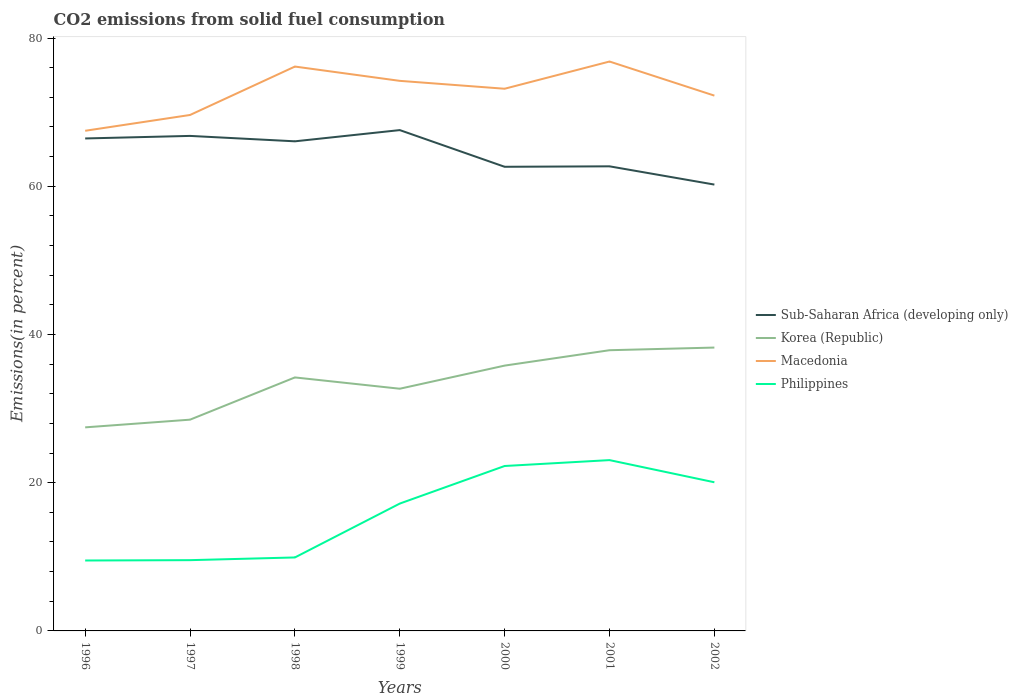Does the line corresponding to Philippines intersect with the line corresponding to Korea (Republic)?
Provide a short and direct response. No. Is the number of lines equal to the number of legend labels?
Offer a terse response. Yes. Across all years, what is the maximum total CO2 emitted in Macedonia?
Give a very brief answer. 67.49. What is the total total CO2 emitted in Korea (Republic) in the graph?
Keep it short and to the point. -4.03. What is the difference between the highest and the second highest total CO2 emitted in Sub-Saharan Africa (developing only)?
Your response must be concise. 7.35. What is the difference between the highest and the lowest total CO2 emitted in Sub-Saharan Africa (developing only)?
Your answer should be very brief. 4. Is the total CO2 emitted in Sub-Saharan Africa (developing only) strictly greater than the total CO2 emitted in Philippines over the years?
Make the answer very short. No. How many lines are there?
Make the answer very short. 4. How many years are there in the graph?
Your answer should be very brief. 7. Does the graph contain any zero values?
Keep it short and to the point. No. Does the graph contain grids?
Your answer should be very brief. No. Where does the legend appear in the graph?
Provide a short and direct response. Center right. What is the title of the graph?
Your answer should be compact. CO2 emissions from solid fuel consumption. Does "Qatar" appear as one of the legend labels in the graph?
Provide a short and direct response. No. What is the label or title of the X-axis?
Your answer should be compact. Years. What is the label or title of the Y-axis?
Offer a terse response. Emissions(in percent). What is the Emissions(in percent) of Sub-Saharan Africa (developing only) in 1996?
Give a very brief answer. 66.45. What is the Emissions(in percent) in Korea (Republic) in 1996?
Offer a very short reply. 27.47. What is the Emissions(in percent) in Macedonia in 1996?
Keep it short and to the point. 67.49. What is the Emissions(in percent) in Philippines in 1996?
Your answer should be very brief. 9.5. What is the Emissions(in percent) in Sub-Saharan Africa (developing only) in 1997?
Your answer should be compact. 66.8. What is the Emissions(in percent) in Korea (Republic) in 1997?
Your answer should be compact. 28.51. What is the Emissions(in percent) of Macedonia in 1997?
Your answer should be very brief. 69.62. What is the Emissions(in percent) in Philippines in 1997?
Keep it short and to the point. 9.55. What is the Emissions(in percent) of Sub-Saharan Africa (developing only) in 1998?
Your answer should be compact. 66.07. What is the Emissions(in percent) in Korea (Republic) in 1998?
Keep it short and to the point. 34.21. What is the Emissions(in percent) in Macedonia in 1998?
Your answer should be very brief. 76.15. What is the Emissions(in percent) of Philippines in 1998?
Offer a very short reply. 9.91. What is the Emissions(in percent) of Sub-Saharan Africa (developing only) in 1999?
Your answer should be compact. 67.58. What is the Emissions(in percent) of Korea (Republic) in 1999?
Your response must be concise. 32.68. What is the Emissions(in percent) of Macedonia in 1999?
Your answer should be compact. 74.23. What is the Emissions(in percent) in Philippines in 1999?
Ensure brevity in your answer.  17.18. What is the Emissions(in percent) in Sub-Saharan Africa (developing only) in 2000?
Keep it short and to the point. 62.63. What is the Emissions(in percent) of Korea (Republic) in 2000?
Offer a very short reply. 35.8. What is the Emissions(in percent) of Macedonia in 2000?
Your answer should be very brief. 73.16. What is the Emissions(in percent) in Philippines in 2000?
Ensure brevity in your answer.  22.26. What is the Emissions(in percent) in Sub-Saharan Africa (developing only) in 2001?
Offer a very short reply. 62.69. What is the Emissions(in percent) of Korea (Republic) in 2001?
Provide a succinct answer. 37.88. What is the Emissions(in percent) of Macedonia in 2001?
Your answer should be very brief. 76.83. What is the Emissions(in percent) in Philippines in 2001?
Your answer should be very brief. 23.05. What is the Emissions(in percent) of Sub-Saharan Africa (developing only) in 2002?
Make the answer very short. 60.23. What is the Emissions(in percent) in Korea (Republic) in 2002?
Offer a terse response. 38.24. What is the Emissions(in percent) of Macedonia in 2002?
Keep it short and to the point. 72.23. What is the Emissions(in percent) in Philippines in 2002?
Keep it short and to the point. 20.06. Across all years, what is the maximum Emissions(in percent) of Sub-Saharan Africa (developing only)?
Make the answer very short. 67.58. Across all years, what is the maximum Emissions(in percent) of Korea (Republic)?
Ensure brevity in your answer.  38.24. Across all years, what is the maximum Emissions(in percent) of Macedonia?
Provide a succinct answer. 76.83. Across all years, what is the maximum Emissions(in percent) in Philippines?
Provide a short and direct response. 23.05. Across all years, what is the minimum Emissions(in percent) of Sub-Saharan Africa (developing only)?
Give a very brief answer. 60.23. Across all years, what is the minimum Emissions(in percent) of Korea (Republic)?
Provide a succinct answer. 27.47. Across all years, what is the minimum Emissions(in percent) of Macedonia?
Keep it short and to the point. 67.49. Across all years, what is the minimum Emissions(in percent) in Philippines?
Provide a succinct answer. 9.5. What is the total Emissions(in percent) of Sub-Saharan Africa (developing only) in the graph?
Your answer should be very brief. 452.45. What is the total Emissions(in percent) in Korea (Republic) in the graph?
Your response must be concise. 234.78. What is the total Emissions(in percent) of Macedonia in the graph?
Your answer should be compact. 509.72. What is the total Emissions(in percent) in Philippines in the graph?
Ensure brevity in your answer.  111.51. What is the difference between the Emissions(in percent) in Sub-Saharan Africa (developing only) in 1996 and that in 1997?
Ensure brevity in your answer.  -0.34. What is the difference between the Emissions(in percent) in Korea (Republic) in 1996 and that in 1997?
Your response must be concise. -1.04. What is the difference between the Emissions(in percent) of Macedonia in 1996 and that in 1997?
Provide a short and direct response. -2.13. What is the difference between the Emissions(in percent) in Philippines in 1996 and that in 1997?
Your answer should be compact. -0.05. What is the difference between the Emissions(in percent) in Sub-Saharan Africa (developing only) in 1996 and that in 1998?
Offer a terse response. 0.39. What is the difference between the Emissions(in percent) in Korea (Republic) in 1996 and that in 1998?
Your answer should be very brief. -6.74. What is the difference between the Emissions(in percent) of Macedonia in 1996 and that in 1998?
Provide a short and direct response. -8.67. What is the difference between the Emissions(in percent) of Philippines in 1996 and that in 1998?
Provide a short and direct response. -0.41. What is the difference between the Emissions(in percent) of Sub-Saharan Africa (developing only) in 1996 and that in 1999?
Your response must be concise. -1.13. What is the difference between the Emissions(in percent) of Korea (Republic) in 1996 and that in 1999?
Your answer should be compact. -5.21. What is the difference between the Emissions(in percent) of Macedonia in 1996 and that in 1999?
Make the answer very short. -6.74. What is the difference between the Emissions(in percent) of Philippines in 1996 and that in 1999?
Offer a terse response. -7.68. What is the difference between the Emissions(in percent) of Sub-Saharan Africa (developing only) in 1996 and that in 2000?
Provide a short and direct response. 3.82. What is the difference between the Emissions(in percent) of Korea (Republic) in 1996 and that in 2000?
Keep it short and to the point. -8.33. What is the difference between the Emissions(in percent) of Macedonia in 1996 and that in 2000?
Your answer should be compact. -5.67. What is the difference between the Emissions(in percent) of Philippines in 1996 and that in 2000?
Keep it short and to the point. -12.75. What is the difference between the Emissions(in percent) of Sub-Saharan Africa (developing only) in 1996 and that in 2001?
Make the answer very short. 3.76. What is the difference between the Emissions(in percent) of Korea (Republic) in 1996 and that in 2001?
Your answer should be very brief. -10.41. What is the difference between the Emissions(in percent) in Macedonia in 1996 and that in 2001?
Your answer should be compact. -9.34. What is the difference between the Emissions(in percent) of Philippines in 1996 and that in 2001?
Provide a succinct answer. -13.55. What is the difference between the Emissions(in percent) of Sub-Saharan Africa (developing only) in 1996 and that in 2002?
Make the answer very short. 6.22. What is the difference between the Emissions(in percent) of Korea (Republic) in 1996 and that in 2002?
Your answer should be very brief. -10.77. What is the difference between the Emissions(in percent) in Macedonia in 1996 and that in 2002?
Provide a succinct answer. -4.74. What is the difference between the Emissions(in percent) of Philippines in 1996 and that in 2002?
Ensure brevity in your answer.  -10.55. What is the difference between the Emissions(in percent) of Sub-Saharan Africa (developing only) in 1997 and that in 1998?
Provide a short and direct response. 0.73. What is the difference between the Emissions(in percent) of Korea (Republic) in 1997 and that in 1998?
Your response must be concise. -5.7. What is the difference between the Emissions(in percent) in Macedonia in 1997 and that in 1998?
Make the answer very short. -6.53. What is the difference between the Emissions(in percent) in Philippines in 1997 and that in 1998?
Ensure brevity in your answer.  -0.37. What is the difference between the Emissions(in percent) in Sub-Saharan Africa (developing only) in 1997 and that in 1999?
Provide a succinct answer. -0.78. What is the difference between the Emissions(in percent) of Korea (Republic) in 1997 and that in 1999?
Offer a terse response. -4.17. What is the difference between the Emissions(in percent) in Macedonia in 1997 and that in 1999?
Provide a succinct answer. -4.61. What is the difference between the Emissions(in percent) of Philippines in 1997 and that in 1999?
Provide a succinct answer. -7.64. What is the difference between the Emissions(in percent) in Sub-Saharan Africa (developing only) in 1997 and that in 2000?
Keep it short and to the point. 4.17. What is the difference between the Emissions(in percent) in Korea (Republic) in 1997 and that in 2000?
Your answer should be very brief. -7.3. What is the difference between the Emissions(in percent) in Macedonia in 1997 and that in 2000?
Keep it short and to the point. -3.54. What is the difference between the Emissions(in percent) in Philippines in 1997 and that in 2000?
Your answer should be very brief. -12.71. What is the difference between the Emissions(in percent) in Sub-Saharan Africa (developing only) in 1997 and that in 2001?
Make the answer very short. 4.1. What is the difference between the Emissions(in percent) of Korea (Republic) in 1997 and that in 2001?
Give a very brief answer. -9.37. What is the difference between the Emissions(in percent) in Macedonia in 1997 and that in 2001?
Your answer should be compact. -7.21. What is the difference between the Emissions(in percent) of Philippines in 1997 and that in 2001?
Give a very brief answer. -13.5. What is the difference between the Emissions(in percent) of Sub-Saharan Africa (developing only) in 1997 and that in 2002?
Provide a short and direct response. 6.57. What is the difference between the Emissions(in percent) of Korea (Republic) in 1997 and that in 2002?
Ensure brevity in your answer.  -9.73. What is the difference between the Emissions(in percent) of Macedonia in 1997 and that in 2002?
Your response must be concise. -2.61. What is the difference between the Emissions(in percent) in Philippines in 1997 and that in 2002?
Give a very brief answer. -10.51. What is the difference between the Emissions(in percent) in Sub-Saharan Africa (developing only) in 1998 and that in 1999?
Your response must be concise. -1.51. What is the difference between the Emissions(in percent) in Korea (Republic) in 1998 and that in 1999?
Offer a terse response. 1.52. What is the difference between the Emissions(in percent) of Macedonia in 1998 and that in 1999?
Your answer should be very brief. 1.93. What is the difference between the Emissions(in percent) of Philippines in 1998 and that in 1999?
Ensure brevity in your answer.  -7.27. What is the difference between the Emissions(in percent) in Sub-Saharan Africa (developing only) in 1998 and that in 2000?
Make the answer very short. 3.44. What is the difference between the Emissions(in percent) of Korea (Republic) in 1998 and that in 2000?
Offer a terse response. -1.6. What is the difference between the Emissions(in percent) of Macedonia in 1998 and that in 2000?
Make the answer very short. 2.99. What is the difference between the Emissions(in percent) in Philippines in 1998 and that in 2000?
Offer a terse response. -12.34. What is the difference between the Emissions(in percent) in Sub-Saharan Africa (developing only) in 1998 and that in 2001?
Your answer should be very brief. 3.38. What is the difference between the Emissions(in percent) of Korea (Republic) in 1998 and that in 2001?
Give a very brief answer. -3.67. What is the difference between the Emissions(in percent) in Macedonia in 1998 and that in 2001?
Your answer should be compact. -0.68. What is the difference between the Emissions(in percent) of Philippines in 1998 and that in 2001?
Give a very brief answer. -13.13. What is the difference between the Emissions(in percent) in Sub-Saharan Africa (developing only) in 1998 and that in 2002?
Your response must be concise. 5.84. What is the difference between the Emissions(in percent) in Korea (Republic) in 1998 and that in 2002?
Offer a very short reply. -4.03. What is the difference between the Emissions(in percent) of Macedonia in 1998 and that in 2002?
Ensure brevity in your answer.  3.92. What is the difference between the Emissions(in percent) in Philippines in 1998 and that in 2002?
Your answer should be compact. -10.14. What is the difference between the Emissions(in percent) of Sub-Saharan Africa (developing only) in 1999 and that in 2000?
Keep it short and to the point. 4.95. What is the difference between the Emissions(in percent) of Korea (Republic) in 1999 and that in 2000?
Give a very brief answer. -3.12. What is the difference between the Emissions(in percent) of Macedonia in 1999 and that in 2000?
Ensure brevity in your answer.  1.06. What is the difference between the Emissions(in percent) in Philippines in 1999 and that in 2000?
Give a very brief answer. -5.07. What is the difference between the Emissions(in percent) in Sub-Saharan Africa (developing only) in 1999 and that in 2001?
Provide a short and direct response. 4.89. What is the difference between the Emissions(in percent) in Korea (Republic) in 1999 and that in 2001?
Provide a short and direct response. -5.2. What is the difference between the Emissions(in percent) in Macedonia in 1999 and that in 2001?
Your answer should be very brief. -2.61. What is the difference between the Emissions(in percent) in Philippines in 1999 and that in 2001?
Make the answer very short. -5.86. What is the difference between the Emissions(in percent) in Sub-Saharan Africa (developing only) in 1999 and that in 2002?
Provide a succinct answer. 7.35. What is the difference between the Emissions(in percent) in Korea (Republic) in 1999 and that in 2002?
Give a very brief answer. -5.56. What is the difference between the Emissions(in percent) of Macedonia in 1999 and that in 2002?
Offer a terse response. 1.99. What is the difference between the Emissions(in percent) in Philippines in 1999 and that in 2002?
Give a very brief answer. -2.87. What is the difference between the Emissions(in percent) in Sub-Saharan Africa (developing only) in 2000 and that in 2001?
Make the answer very short. -0.06. What is the difference between the Emissions(in percent) in Korea (Republic) in 2000 and that in 2001?
Make the answer very short. -2.08. What is the difference between the Emissions(in percent) of Macedonia in 2000 and that in 2001?
Your response must be concise. -3.67. What is the difference between the Emissions(in percent) of Philippines in 2000 and that in 2001?
Keep it short and to the point. -0.79. What is the difference between the Emissions(in percent) in Sub-Saharan Africa (developing only) in 2000 and that in 2002?
Make the answer very short. 2.4. What is the difference between the Emissions(in percent) in Korea (Republic) in 2000 and that in 2002?
Offer a terse response. -2.43. What is the difference between the Emissions(in percent) of Macedonia in 2000 and that in 2002?
Give a very brief answer. 0.93. What is the difference between the Emissions(in percent) of Philippines in 2000 and that in 2002?
Give a very brief answer. 2.2. What is the difference between the Emissions(in percent) in Sub-Saharan Africa (developing only) in 2001 and that in 2002?
Offer a terse response. 2.46. What is the difference between the Emissions(in percent) of Korea (Republic) in 2001 and that in 2002?
Make the answer very short. -0.36. What is the difference between the Emissions(in percent) of Macedonia in 2001 and that in 2002?
Ensure brevity in your answer.  4.6. What is the difference between the Emissions(in percent) of Philippines in 2001 and that in 2002?
Your answer should be compact. 2.99. What is the difference between the Emissions(in percent) of Sub-Saharan Africa (developing only) in 1996 and the Emissions(in percent) of Korea (Republic) in 1997?
Provide a succinct answer. 37.95. What is the difference between the Emissions(in percent) of Sub-Saharan Africa (developing only) in 1996 and the Emissions(in percent) of Macedonia in 1997?
Keep it short and to the point. -3.17. What is the difference between the Emissions(in percent) of Sub-Saharan Africa (developing only) in 1996 and the Emissions(in percent) of Philippines in 1997?
Your answer should be very brief. 56.9. What is the difference between the Emissions(in percent) in Korea (Republic) in 1996 and the Emissions(in percent) in Macedonia in 1997?
Provide a short and direct response. -42.15. What is the difference between the Emissions(in percent) of Korea (Republic) in 1996 and the Emissions(in percent) of Philippines in 1997?
Your answer should be compact. 17.92. What is the difference between the Emissions(in percent) in Macedonia in 1996 and the Emissions(in percent) in Philippines in 1997?
Your answer should be compact. 57.94. What is the difference between the Emissions(in percent) in Sub-Saharan Africa (developing only) in 1996 and the Emissions(in percent) in Korea (Republic) in 1998?
Keep it short and to the point. 32.25. What is the difference between the Emissions(in percent) of Sub-Saharan Africa (developing only) in 1996 and the Emissions(in percent) of Macedonia in 1998?
Offer a terse response. -9.7. What is the difference between the Emissions(in percent) in Sub-Saharan Africa (developing only) in 1996 and the Emissions(in percent) in Philippines in 1998?
Your answer should be compact. 56.54. What is the difference between the Emissions(in percent) of Korea (Republic) in 1996 and the Emissions(in percent) of Macedonia in 1998?
Your answer should be very brief. -48.69. What is the difference between the Emissions(in percent) of Korea (Republic) in 1996 and the Emissions(in percent) of Philippines in 1998?
Provide a short and direct response. 17.55. What is the difference between the Emissions(in percent) of Macedonia in 1996 and the Emissions(in percent) of Philippines in 1998?
Keep it short and to the point. 57.57. What is the difference between the Emissions(in percent) of Sub-Saharan Africa (developing only) in 1996 and the Emissions(in percent) of Korea (Republic) in 1999?
Your answer should be compact. 33.77. What is the difference between the Emissions(in percent) of Sub-Saharan Africa (developing only) in 1996 and the Emissions(in percent) of Macedonia in 1999?
Offer a very short reply. -7.77. What is the difference between the Emissions(in percent) in Sub-Saharan Africa (developing only) in 1996 and the Emissions(in percent) in Philippines in 1999?
Your answer should be compact. 49.27. What is the difference between the Emissions(in percent) in Korea (Republic) in 1996 and the Emissions(in percent) in Macedonia in 1999?
Your answer should be very brief. -46.76. What is the difference between the Emissions(in percent) of Korea (Republic) in 1996 and the Emissions(in percent) of Philippines in 1999?
Provide a short and direct response. 10.28. What is the difference between the Emissions(in percent) in Macedonia in 1996 and the Emissions(in percent) in Philippines in 1999?
Your answer should be compact. 50.3. What is the difference between the Emissions(in percent) in Sub-Saharan Africa (developing only) in 1996 and the Emissions(in percent) in Korea (Republic) in 2000?
Keep it short and to the point. 30.65. What is the difference between the Emissions(in percent) of Sub-Saharan Africa (developing only) in 1996 and the Emissions(in percent) of Macedonia in 2000?
Keep it short and to the point. -6.71. What is the difference between the Emissions(in percent) of Sub-Saharan Africa (developing only) in 1996 and the Emissions(in percent) of Philippines in 2000?
Give a very brief answer. 44.2. What is the difference between the Emissions(in percent) of Korea (Republic) in 1996 and the Emissions(in percent) of Macedonia in 2000?
Your answer should be compact. -45.69. What is the difference between the Emissions(in percent) of Korea (Republic) in 1996 and the Emissions(in percent) of Philippines in 2000?
Give a very brief answer. 5.21. What is the difference between the Emissions(in percent) in Macedonia in 1996 and the Emissions(in percent) in Philippines in 2000?
Ensure brevity in your answer.  45.23. What is the difference between the Emissions(in percent) in Sub-Saharan Africa (developing only) in 1996 and the Emissions(in percent) in Korea (Republic) in 2001?
Provide a succinct answer. 28.57. What is the difference between the Emissions(in percent) in Sub-Saharan Africa (developing only) in 1996 and the Emissions(in percent) in Macedonia in 2001?
Your response must be concise. -10.38. What is the difference between the Emissions(in percent) of Sub-Saharan Africa (developing only) in 1996 and the Emissions(in percent) of Philippines in 2001?
Keep it short and to the point. 43.4. What is the difference between the Emissions(in percent) in Korea (Republic) in 1996 and the Emissions(in percent) in Macedonia in 2001?
Keep it short and to the point. -49.37. What is the difference between the Emissions(in percent) in Korea (Republic) in 1996 and the Emissions(in percent) in Philippines in 2001?
Keep it short and to the point. 4.42. What is the difference between the Emissions(in percent) of Macedonia in 1996 and the Emissions(in percent) of Philippines in 2001?
Give a very brief answer. 44.44. What is the difference between the Emissions(in percent) of Sub-Saharan Africa (developing only) in 1996 and the Emissions(in percent) of Korea (Republic) in 2002?
Ensure brevity in your answer.  28.22. What is the difference between the Emissions(in percent) of Sub-Saharan Africa (developing only) in 1996 and the Emissions(in percent) of Macedonia in 2002?
Provide a succinct answer. -5.78. What is the difference between the Emissions(in percent) in Sub-Saharan Africa (developing only) in 1996 and the Emissions(in percent) in Philippines in 2002?
Provide a short and direct response. 46.4. What is the difference between the Emissions(in percent) of Korea (Republic) in 1996 and the Emissions(in percent) of Macedonia in 2002?
Make the answer very short. -44.77. What is the difference between the Emissions(in percent) in Korea (Republic) in 1996 and the Emissions(in percent) in Philippines in 2002?
Provide a short and direct response. 7.41. What is the difference between the Emissions(in percent) of Macedonia in 1996 and the Emissions(in percent) of Philippines in 2002?
Ensure brevity in your answer.  47.43. What is the difference between the Emissions(in percent) of Sub-Saharan Africa (developing only) in 1997 and the Emissions(in percent) of Korea (Republic) in 1998?
Provide a short and direct response. 32.59. What is the difference between the Emissions(in percent) in Sub-Saharan Africa (developing only) in 1997 and the Emissions(in percent) in Macedonia in 1998?
Give a very brief answer. -9.36. What is the difference between the Emissions(in percent) of Sub-Saharan Africa (developing only) in 1997 and the Emissions(in percent) of Philippines in 1998?
Provide a short and direct response. 56.88. What is the difference between the Emissions(in percent) in Korea (Republic) in 1997 and the Emissions(in percent) in Macedonia in 1998?
Your response must be concise. -47.65. What is the difference between the Emissions(in percent) of Korea (Republic) in 1997 and the Emissions(in percent) of Philippines in 1998?
Give a very brief answer. 18.59. What is the difference between the Emissions(in percent) in Macedonia in 1997 and the Emissions(in percent) in Philippines in 1998?
Your answer should be compact. 59.71. What is the difference between the Emissions(in percent) in Sub-Saharan Africa (developing only) in 1997 and the Emissions(in percent) in Korea (Republic) in 1999?
Offer a very short reply. 34.11. What is the difference between the Emissions(in percent) of Sub-Saharan Africa (developing only) in 1997 and the Emissions(in percent) of Macedonia in 1999?
Provide a short and direct response. -7.43. What is the difference between the Emissions(in percent) in Sub-Saharan Africa (developing only) in 1997 and the Emissions(in percent) in Philippines in 1999?
Make the answer very short. 49.61. What is the difference between the Emissions(in percent) in Korea (Republic) in 1997 and the Emissions(in percent) in Macedonia in 1999?
Ensure brevity in your answer.  -45.72. What is the difference between the Emissions(in percent) of Korea (Republic) in 1997 and the Emissions(in percent) of Philippines in 1999?
Make the answer very short. 11.32. What is the difference between the Emissions(in percent) in Macedonia in 1997 and the Emissions(in percent) in Philippines in 1999?
Provide a short and direct response. 52.44. What is the difference between the Emissions(in percent) of Sub-Saharan Africa (developing only) in 1997 and the Emissions(in percent) of Korea (Republic) in 2000?
Give a very brief answer. 30.99. What is the difference between the Emissions(in percent) of Sub-Saharan Africa (developing only) in 1997 and the Emissions(in percent) of Macedonia in 2000?
Your answer should be very brief. -6.37. What is the difference between the Emissions(in percent) in Sub-Saharan Africa (developing only) in 1997 and the Emissions(in percent) in Philippines in 2000?
Offer a terse response. 44.54. What is the difference between the Emissions(in percent) of Korea (Republic) in 1997 and the Emissions(in percent) of Macedonia in 2000?
Your response must be concise. -44.65. What is the difference between the Emissions(in percent) of Korea (Republic) in 1997 and the Emissions(in percent) of Philippines in 2000?
Your response must be concise. 6.25. What is the difference between the Emissions(in percent) in Macedonia in 1997 and the Emissions(in percent) in Philippines in 2000?
Keep it short and to the point. 47.37. What is the difference between the Emissions(in percent) of Sub-Saharan Africa (developing only) in 1997 and the Emissions(in percent) of Korea (Republic) in 2001?
Provide a short and direct response. 28.92. What is the difference between the Emissions(in percent) in Sub-Saharan Africa (developing only) in 1997 and the Emissions(in percent) in Macedonia in 2001?
Provide a succinct answer. -10.04. What is the difference between the Emissions(in percent) in Sub-Saharan Africa (developing only) in 1997 and the Emissions(in percent) in Philippines in 2001?
Make the answer very short. 43.75. What is the difference between the Emissions(in percent) of Korea (Republic) in 1997 and the Emissions(in percent) of Macedonia in 2001?
Keep it short and to the point. -48.33. What is the difference between the Emissions(in percent) of Korea (Republic) in 1997 and the Emissions(in percent) of Philippines in 2001?
Offer a very short reply. 5.46. What is the difference between the Emissions(in percent) of Macedonia in 1997 and the Emissions(in percent) of Philippines in 2001?
Make the answer very short. 46.57. What is the difference between the Emissions(in percent) in Sub-Saharan Africa (developing only) in 1997 and the Emissions(in percent) in Korea (Republic) in 2002?
Ensure brevity in your answer.  28.56. What is the difference between the Emissions(in percent) of Sub-Saharan Africa (developing only) in 1997 and the Emissions(in percent) of Macedonia in 2002?
Provide a short and direct response. -5.44. What is the difference between the Emissions(in percent) of Sub-Saharan Africa (developing only) in 1997 and the Emissions(in percent) of Philippines in 2002?
Make the answer very short. 46.74. What is the difference between the Emissions(in percent) in Korea (Republic) in 1997 and the Emissions(in percent) in Macedonia in 2002?
Provide a succinct answer. -43.73. What is the difference between the Emissions(in percent) of Korea (Republic) in 1997 and the Emissions(in percent) of Philippines in 2002?
Ensure brevity in your answer.  8.45. What is the difference between the Emissions(in percent) of Macedonia in 1997 and the Emissions(in percent) of Philippines in 2002?
Keep it short and to the point. 49.56. What is the difference between the Emissions(in percent) of Sub-Saharan Africa (developing only) in 1998 and the Emissions(in percent) of Korea (Republic) in 1999?
Ensure brevity in your answer.  33.39. What is the difference between the Emissions(in percent) of Sub-Saharan Africa (developing only) in 1998 and the Emissions(in percent) of Macedonia in 1999?
Offer a very short reply. -8.16. What is the difference between the Emissions(in percent) in Sub-Saharan Africa (developing only) in 1998 and the Emissions(in percent) in Philippines in 1999?
Make the answer very short. 48.88. What is the difference between the Emissions(in percent) of Korea (Republic) in 1998 and the Emissions(in percent) of Macedonia in 1999?
Ensure brevity in your answer.  -40.02. What is the difference between the Emissions(in percent) of Korea (Republic) in 1998 and the Emissions(in percent) of Philippines in 1999?
Your answer should be compact. 17.02. What is the difference between the Emissions(in percent) of Macedonia in 1998 and the Emissions(in percent) of Philippines in 1999?
Keep it short and to the point. 58.97. What is the difference between the Emissions(in percent) in Sub-Saharan Africa (developing only) in 1998 and the Emissions(in percent) in Korea (Republic) in 2000?
Your response must be concise. 30.26. What is the difference between the Emissions(in percent) in Sub-Saharan Africa (developing only) in 1998 and the Emissions(in percent) in Macedonia in 2000?
Your answer should be very brief. -7.09. What is the difference between the Emissions(in percent) of Sub-Saharan Africa (developing only) in 1998 and the Emissions(in percent) of Philippines in 2000?
Ensure brevity in your answer.  43.81. What is the difference between the Emissions(in percent) of Korea (Republic) in 1998 and the Emissions(in percent) of Macedonia in 2000?
Provide a short and direct response. -38.96. What is the difference between the Emissions(in percent) in Korea (Republic) in 1998 and the Emissions(in percent) in Philippines in 2000?
Ensure brevity in your answer.  11.95. What is the difference between the Emissions(in percent) in Macedonia in 1998 and the Emissions(in percent) in Philippines in 2000?
Ensure brevity in your answer.  53.9. What is the difference between the Emissions(in percent) of Sub-Saharan Africa (developing only) in 1998 and the Emissions(in percent) of Korea (Republic) in 2001?
Your answer should be compact. 28.19. What is the difference between the Emissions(in percent) of Sub-Saharan Africa (developing only) in 1998 and the Emissions(in percent) of Macedonia in 2001?
Your answer should be very brief. -10.77. What is the difference between the Emissions(in percent) in Sub-Saharan Africa (developing only) in 1998 and the Emissions(in percent) in Philippines in 2001?
Provide a succinct answer. 43.02. What is the difference between the Emissions(in percent) of Korea (Republic) in 1998 and the Emissions(in percent) of Macedonia in 2001?
Offer a very short reply. -42.63. What is the difference between the Emissions(in percent) of Korea (Republic) in 1998 and the Emissions(in percent) of Philippines in 2001?
Offer a terse response. 11.16. What is the difference between the Emissions(in percent) of Macedonia in 1998 and the Emissions(in percent) of Philippines in 2001?
Your answer should be very brief. 53.11. What is the difference between the Emissions(in percent) in Sub-Saharan Africa (developing only) in 1998 and the Emissions(in percent) in Korea (Republic) in 2002?
Offer a very short reply. 27.83. What is the difference between the Emissions(in percent) of Sub-Saharan Africa (developing only) in 1998 and the Emissions(in percent) of Macedonia in 2002?
Offer a terse response. -6.17. What is the difference between the Emissions(in percent) of Sub-Saharan Africa (developing only) in 1998 and the Emissions(in percent) of Philippines in 2002?
Your answer should be very brief. 46.01. What is the difference between the Emissions(in percent) in Korea (Republic) in 1998 and the Emissions(in percent) in Macedonia in 2002?
Make the answer very short. -38.03. What is the difference between the Emissions(in percent) in Korea (Republic) in 1998 and the Emissions(in percent) in Philippines in 2002?
Your answer should be very brief. 14.15. What is the difference between the Emissions(in percent) of Macedonia in 1998 and the Emissions(in percent) of Philippines in 2002?
Offer a very short reply. 56.1. What is the difference between the Emissions(in percent) of Sub-Saharan Africa (developing only) in 1999 and the Emissions(in percent) of Korea (Republic) in 2000?
Ensure brevity in your answer.  31.78. What is the difference between the Emissions(in percent) of Sub-Saharan Africa (developing only) in 1999 and the Emissions(in percent) of Macedonia in 2000?
Your answer should be very brief. -5.58. What is the difference between the Emissions(in percent) of Sub-Saharan Africa (developing only) in 1999 and the Emissions(in percent) of Philippines in 2000?
Ensure brevity in your answer.  45.33. What is the difference between the Emissions(in percent) of Korea (Republic) in 1999 and the Emissions(in percent) of Macedonia in 2000?
Keep it short and to the point. -40.48. What is the difference between the Emissions(in percent) in Korea (Republic) in 1999 and the Emissions(in percent) in Philippines in 2000?
Give a very brief answer. 10.43. What is the difference between the Emissions(in percent) in Macedonia in 1999 and the Emissions(in percent) in Philippines in 2000?
Provide a short and direct response. 51.97. What is the difference between the Emissions(in percent) in Sub-Saharan Africa (developing only) in 1999 and the Emissions(in percent) in Korea (Republic) in 2001?
Ensure brevity in your answer.  29.7. What is the difference between the Emissions(in percent) of Sub-Saharan Africa (developing only) in 1999 and the Emissions(in percent) of Macedonia in 2001?
Keep it short and to the point. -9.25. What is the difference between the Emissions(in percent) of Sub-Saharan Africa (developing only) in 1999 and the Emissions(in percent) of Philippines in 2001?
Your response must be concise. 44.53. What is the difference between the Emissions(in percent) of Korea (Republic) in 1999 and the Emissions(in percent) of Macedonia in 2001?
Your answer should be very brief. -44.15. What is the difference between the Emissions(in percent) of Korea (Republic) in 1999 and the Emissions(in percent) of Philippines in 2001?
Your response must be concise. 9.63. What is the difference between the Emissions(in percent) of Macedonia in 1999 and the Emissions(in percent) of Philippines in 2001?
Give a very brief answer. 51.18. What is the difference between the Emissions(in percent) of Sub-Saharan Africa (developing only) in 1999 and the Emissions(in percent) of Korea (Republic) in 2002?
Make the answer very short. 29.34. What is the difference between the Emissions(in percent) in Sub-Saharan Africa (developing only) in 1999 and the Emissions(in percent) in Macedonia in 2002?
Your answer should be very brief. -4.65. What is the difference between the Emissions(in percent) in Sub-Saharan Africa (developing only) in 1999 and the Emissions(in percent) in Philippines in 2002?
Make the answer very short. 47.52. What is the difference between the Emissions(in percent) in Korea (Republic) in 1999 and the Emissions(in percent) in Macedonia in 2002?
Ensure brevity in your answer.  -39.55. What is the difference between the Emissions(in percent) in Korea (Republic) in 1999 and the Emissions(in percent) in Philippines in 2002?
Offer a terse response. 12.62. What is the difference between the Emissions(in percent) of Macedonia in 1999 and the Emissions(in percent) of Philippines in 2002?
Provide a succinct answer. 54.17. What is the difference between the Emissions(in percent) of Sub-Saharan Africa (developing only) in 2000 and the Emissions(in percent) of Korea (Republic) in 2001?
Provide a short and direct response. 24.75. What is the difference between the Emissions(in percent) in Sub-Saharan Africa (developing only) in 2000 and the Emissions(in percent) in Macedonia in 2001?
Provide a succinct answer. -14.2. What is the difference between the Emissions(in percent) in Sub-Saharan Africa (developing only) in 2000 and the Emissions(in percent) in Philippines in 2001?
Provide a short and direct response. 39.58. What is the difference between the Emissions(in percent) in Korea (Republic) in 2000 and the Emissions(in percent) in Macedonia in 2001?
Offer a terse response. -41.03. What is the difference between the Emissions(in percent) of Korea (Republic) in 2000 and the Emissions(in percent) of Philippines in 2001?
Your response must be concise. 12.75. What is the difference between the Emissions(in percent) in Macedonia in 2000 and the Emissions(in percent) in Philippines in 2001?
Your answer should be very brief. 50.11. What is the difference between the Emissions(in percent) of Sub-Saharan Africa (developing only) in 2000 and the Emissions(in percent) of Korea (Republic) in 2002?
Offer a very short reply. 24.39. What is the difference between the Emissions(in percent) of Sub-Saharan Africa (developing only) in 2000 and the Emissions(in percent) of Macedonia in 2002?
Provide a short and direct response. -9.6. What is the difference between the Emissions(in percent) in Sub-Saharan Africa (developing only) in 2000 and the Emissions(in percent) in Philippines in 2002?
Your answer should be compact. 42.57. What is the difference between the Emissions(in percent) in Korea (Republic) in 2000 and the Emissions(in percent) in Macedonia in 2002?
Give a very brief answer. -36.43. What is the difference between the Emissions(in percent) of Korea (Republic) in 2000 and the Emissions(in percent) of Philippines in 2002?
Offer a very short reply. 15.74. What is the difference between the Emissions(in percent) of Macedonia in 2000 and the Emissions(in percent) of Philippines in 2002?
Offer a terse response. 53.1. What is the difference between the Emissions(in percent) in Sub-Saharan Africa (developing only) in 2001 and the Emissions(in percent) in Korea (Republic) in 2002?
Offer a terse response. 24.45. What is the difference between the Emissions(in percent) in Sub-Saharan Africa (developing only) in 2001 and the Emissions(in percent) in Macedonia in 2002?
Ensure brevity in your answer.  -9.54. What is the difference between the Emissions(in percent) in Sub-Saharan Africa (developing only) in 2001 and the Emissions(in percent) in Philippines in 2002?
Offer a very short reply. 42.63. What is the difference between the Emissions(in percent) of Korea (Republic) in 2001 and the Emissions(in percent) of Macedonia in 2002?
Ensure brevity in your answer.  -34.35. What is the difference between the Emissions(in percent) of Korea (Republic) in 2001 and the Emissions(in percent) of Philippines in 2002?
Provide a succinct answer. 17.82. What is the difference between the Emissions(in percent) of Macedonia in 2001 and the Emissions(in percent) of Philippines in 2002?
Make the answer very short. 56.78. What is the average Emissions(in percent) of Sub-Saharan Africa (developing only) per year?
Offer a terse response. 64.64. What is the average Emissions(in percent) in Korea (Republic) per year?
Ensure brevity in your answer.  33.54. What is the average Emissions(in percent) of Macedonia per year?
Provide a succinct answer. 72.82. What is the average Emissions(in percent) in Philippines per year?
Offer a terse response. 15.93. In the year 1996, what is the difference between the Emissions(in percent) in Sub-Saharan Africa (developing only) and Emissions(in percent) in Korea (Republic)?
Ensure brevity in your answer.  38.98. In the year 1996, what is the difference between the Emissions(in percent) of Sub-Saharan Africa (developing only) and Emissions(in percent) of Macedonia?
Offer a very short reply. -1.04. In the year 1996, what is the difference between the Emissions(in percent) of Sub-Saharan Africa (developing only) and Emissions(in percent) of Philippines?
Keep it short and to the point. 56.95. In the year 1996, what is the difference between the Emissions(in percent) of Korea (Republic) and Emissions(in percent) of Macedonia?
Make the answer very short. -40.02. In the year 1996, what is the difference between the Emissions(in percent) in Korea (Republic) and Emissions(in percent) in Philippines?
Your response must be concise. 17.97. In the year 1996, what is the difference between the Emissions(in percent) in Macedonia and Emissions(in percent) in Philippines?
Ensure brevity in your answer.  57.99. In the year 1997, what is the difference between the Emissions(in percent) in Sub-Saharan Africa (developing only) and Emissions(in percent) in Korea (Republic)?
Make the answer very short. 38.29. In the year 1997, what is the difference between the Emissions(in percent) of Sub-Saharan Africa (developing only) and Emissions(in percent) of Macedonia?
Keep it short and to the point. -2.82. In the year 1997, what is the difference between the Emissions(in percent) of Sub-Saharan Africa (developing only) and Emissions(in percent) of Philippines?
Offer a terse response. 57.25. In the year 1997, what is the difference between the Emissions(in percent) in Korea (Republic) and Emissions(in percent) in Macedonia?
Make the answer very short. -41.11. In the year 1997, what is the difference between the Emissions(in percent) of Korea (Republic) and Emissions(in percent) of Philippines?
Give a very brief answer. 18.96. In the year 1997, what is the difference between the Emissions(in percent) of Macedonia and Emissions(in percent) of Philippines?
Your response must be concise. 60.07. In the year 1998, what is the difference between the Emissions(in percent) in Sub-Saharan Africa (developing only) and Emissions(in percent) in Korea (Republic)?
Your answer should be very brief. 31.86. In the year 1998, what is the difference between the Emissions(in percent) of Sub-Saharan Africa (developing only) and Emissions(in percent) of Macedonia?
Offer a very short reply. -10.09. In the year 1998, what is the difference between the Emissions(in percent) in Sub-Saharan Africa (developing only) and Emissions(in percent) in Philippines?
Make the answer very short. 56.15. In the year 1998, what is the difference between the Emissions(in percent) of Korea (Republic) and Emissions(in percent) of Macedonia?
Provide a succinct answer. -41.95. In the year 1998, what is the difference between the Emissions(in percent) of Korea (Republic) and Emissions(in percent) of Philippines?
Give a very brief answer. 24.29. In the year 1998, what is the difference between the Emissions(in percent) in Macedonia and Emissions(in percent) in Philippines?
Provide a short and direct response. 66.24. In the year 1999, what is the difference between the Emissions(in percent) in Sub-Saharan Africa (developing only) and Emissions(in percent) in Korea (Republic)?
Provide a short and direct response. 34.9. In the year 1999, what is the difference between the Emissions(in percent) of Sub-Saharan Africa (developing only) and Emissions(in percent) of Macedonia?
Keep it short and to the point. -6.65. In the year 1999, what is the difference between the Emissions(in percent) in Sub-Saharan Africa (developing only) and Emissions(in percent) in Philippines?
Your answer should be compact. 50.4. In the year 1999, what is the difference between the Emissions(in percent) of Korea (Republic) and Emissions(in percent) of Macedonia?
Provide a short and direct response. -41.54. In the year 1999, what is the difference between the Emissions(in percent) of Korea (Republic) and Emissions(in percent) of Philippines?
Provide a short and direct response. 15.5. In the year 1999, what is the difference between the Emissions(in percent) in Macedonia and Emissions(in percent) in Philippines?
Offer a very short reply. 57.04. In the year 2000, what is the difference between the Emissions(in percent) in Sub-Saharan Africa (developing only) and Emissions(in percent) in Korea (Republic)?
Your answer should be very brief. 26.83. In the year 2000, what is the difference between the Emissions(in percent) in Sub-Saharan Africa (developing only) and Emissions(in percent) in Macedonia?
Provide a succinct answer. -10.53. In the year 2000, what is the difference between the Emissions(in percent) of Sub-Saharan Africa (developing only) and Emissions(in percent) of Philippines?
Your answer should be compact. 40.37. In the year 2000, what is the difference between the Emissions(in percent) in Korea (Republic) and Emissions(in percent) in Macedonia?
Provide a succinct answer. -37.36. In the year 2000, what is the difference between the Emissions(in percent) in Korea (Republic) and Emissions(in percent) in Philippines?
Provide a short and direct response. 13.55. In the year 2000, what is the difference between the Emissions(in percent) in Macedonia and Emissions(in percent) in Philippines?
Offer a very short reply. 50.91. In the year 2001, what is the difference between the Emissions(in percent) in Sub-Saharan Africa (developing only) and Emissions(in percent) in Korea (Republic)?
Ensure brevity in your answer.  24.81. In the year 2001, what is the difference between the Emissions(in percent) in Sub-Saharan Africa (developing only) and Emissions(in percent) in Macedonia?
Provide a short and direct response. -14.14. In the year 2001, what is the difference between the Emissions(in percent) of Sub-Saharan Africa (developing only) and Emissions(in percent) of Philippines?
Your answer should be compact. 39.64. In the year 2001, what is the difference between the Emissions(in percent) in Korea (Republic) and Emissions(in percent) in Macedonia?
Ensure brevity in your answer.  -38.96. In the year 2001, what is the difference between the Emissions(in percent) in Korea (Republic) and Emissions(in percent) in Philippines?
Offer a very short reply. 14.83. In the year 2001, what is the difference between the Emissions(in percent) in Macedonia and Emissions(in percent) in Philippines?
Your answer should be compact. 53.78. In the year 2002, what is the difference between the Emissions(in percent) of Sub-Saharan Africa (developing only) and Emissions(in percent) of Korea (Republic)?
Offer a very short reply. 21.99. In the year 2002, what is the difference between the Emissions(in percent) of Sub-Saharan Africa (developing only) and Emissions(in percent) of Macedonia?
Offer a terse response. -12. In the year 2002, what is the difference between the Emissions(in percent) in Sub-Saharan Africa (developing only) and Emissions(in percent) in Philippines?
Offer a terse response. 40.17. In the year 2002, what is the difference between the Emissions(in percent) of Korea (Republic) and Emissions(in percent) of Macedonia?
Give a very brief answer. -34. In the year 2002, what is the difference between the Emissions(in percent) of Korea (Republic) and Emissions(in percent) of Philippines?
Your answer should be very brief. 18.18. In the year 2002, what is the difference between the Emissions(in percent) in Macedonia and Emissions(in percent) in Philippines?
Give a very brief answer. 52.18. What is the ratio of the Emissions(in percent) of Korea (Republic) in 1996 to that in 1997?
Your response must be concise. 0.96. What is the ratio of the Emissions(in percent) in Macedonia in 1996 to that in 1997?
Make the answer very short. 0.97. What is the ratio of the Emissions(in percent) of Sub-Saharan Africa (developing only) in 1996 to that in 1998?
Your response must be concise. 1.01. What is the ratio of the Emissions(in percent) of Korea (Republic) in 1996 to that in 1998?
Your answer should be very brief. 0.8. What is the ratio of the Emissions(in percent) in Macedonia in 1996 to that in 1998?
Give a very brief answer. 0.89. What is the ratio of the Emissions(in percent) in Philippines in 1996 to that in 1998?
Your answer should be very brief. 0.96. What is the ratio of the Emissions(in percent) in Sub-Saharan Africa (developing only) in 1996 to that in 1999?
Give a very brief answer. 0.98. What is the ratio of the Emissions(in percent) of Korea (Republic) in 1996 to that in 1999?
Provide a short and direct response. 0.84. What is the ratio of the Emissions(in percent) in Macedonia in 1996 to that in 1999?
Make the answer very short. 0.91. What is the ratio of the Emissions(in percent) in Philippines in 1996 to that in 1999?
Offer a very short reply. 0.55. What is the ratio of the Emissions(in percent) in Sub-Saharan Africa (developing only) in 1996 to that in 2000?
Give a very brief answer. 1.06. What is the ratio of the Emissions(in percent) of Korea (Republic) in 1996 to that in 2000?
Ensure brevity in your answer.  0.77. What is the ratio of the Emissions(in percent) of Macedonia in 1996 to that in 2000?
Make the answer very short. 0.92. What is the ratio of the Emissions(in percent) in Philippines in 1996 to that in 2000?
Your answer should be compact. 0.43. What is the ratio of the Emissions(in percent) in Sub-Saharan Africa (developing only) in 1996 to that in 2001?
Offer a terse response. 1.06. What is the ratio of the Emissions(in percent) of Korea (Republic) in 1996 to that in 2001?
Provide a short and direct response. 0.73. What is the ratio of the Emissions(in percent) in Macedonia in 1996 to that in 2001?
Give a very brief answer. 0.88. What is the ratio of the Emissions(in percent) of Philippines in 1996 to that in 2001?
Provide a succinct answer. 0.41. What is the ratio of the Emissions(in percent) in Sub-Saharan Africa (developing only) in 1996 to that in 2002?
Give a very brief answer. 1.1. What is the ratio of the Emissions(in percent) in Korea (Republic) in 1996 to that in 2002?
Your answer should be very brief. 0.72. What is the ratio of the Emissions(in percent) of Macedonia in 1996 to that in 2002?
Keep it short and to the point. 0.93. What is the ratio of the Emissions(in percent) of Philippines in 1996 to that in 2002?
Offer a terse response. 0.47. What is the ratio of the Emissions(in percent) of Korea (Republic) in 1997 to that in 1998?
Ensure brevity in your answer.  0.83. What is the ratio of the Emissions(in percent) in Macedonia in 1997 to that in 1998?
Your answer should be compact. 0.91. What is the ratio of the Emissions(in percent) in Philippines in 1997 to that in 1998?
Make the answer very short. 0.96. What is the ratio of the Emissions(in percent) of Sub-Saharan Africa (developing only) in 1997 to that in 1999?
Your response must be concise. 0.99. What is the ratio of the Emissions(in percent) of Korea (Republic) in 1997 to that in 1999?
Offer a very short reply. 0.87. What is the ratio of the Emissions(in percent) in Macedonia in 1997 to that in 1999?
Your answer should be very brief. 0.94. What is the ratio of the Emissions(in percent) of Philippines in 1997 to that in 1999?
Your answer should be very brief. 0.56. What is the ratio of the Emissions(in percent) of Sub-Saharan Africa (developing only) in 1997 to that in 2000?
Your response must be concise. 1.07. What is the ratio of the Emissions(in percent) in Korea (Republic) in 1997 to that in 2000?
Keep it short and to the point. 0.8. What is the ratio of the Emissions(in percent) of Macedonia in 1997 to that in 2000?
Keep it short and to the point. 0.95. What is the ratio of the Emissions(in percent) in Philippines in 1997 to that in 2000?
Your answer should be very brief. 0.43. What is the ratio of the Emissions(in percent) in Sub-Saharan Africa (developing only) in 1997 to that in 2001?
Provide a succinct answer. 1.07. What is the ratio of the Emissions(in percent) in Korea (Republic) in 1997 to that in 2001?
Give a very brief answer. 0.75. What is the ratio of the Emissions(in percent) of Macedonia in 1997 to that in 2001?
Ensure brevity in your answer.  0.91. What is the ratio of the Emissions(in percent) of Philippines in 1997 to that in 2001?
Keep it short and to the point. 0.41. What is the ratio of the Emissions(in percent) in Sub-Saharan Africa (developing only) in 1997 to that in 2002?
Give a very brief answer. 1.11. What is the ratio of the Emissions(in percent) of Korea (Republic) in 1997 to that in 2002?
Your response must be concise. 0.75. What is the ratio of the Emissions(in percent) in Macedonia in 1997 to that in 2002?
Provide a succinct answer. 0.96. What is the ratio of the Emissions(in percent) in Philippines in 1997 to that in 2002?
Make the answer very short. 0.48. What is the ratio of the Emissions(in percent) of Sub-Saharan Africa (developing only) in 1998 to that in 1999?
Ensure brevity in your answer.  0.98. What is the ratio of the Emissions(in percent) of Korea (Republic) in 1998 to that in 1999?
Offer a very short reply. 1.05. What is the ratio of the Emissions(in percent) of Macedonia in 1998 to that in 1999?
Offer a very short reply. 1.03. What is the ratio of the Emissions(in percent) of Philippines in 1998 to that in 1999?
Make the answer very short. 0.58. What is the ratio of the Emissions(in percent) of Sub-Saharan Africa (developing only) in 1998 to that in 2000?
Your response must be concise. 1.05. What is the ratio of the Emissions(in percent) of Korea (Republic) in 1998 to that in 2000?
Your answer should be very brief. 0.96. What is the ratio of the Emissions(in percent) in Macedonia in 1998 to that in 2000?
Offer a very short reply. 1.04. What is the ratio of the Emissions(in percent) of Philippines in 1998 to that in 2000?
Your answer should be very brief. 0.45. What is the ratio of the Emissions(in percent) in Sub-Saharan Africa (developing only) in 1998 to that in 2001?
Your answer should be compact. 1.05. What is the ratio of the Emissions(in percent) of Korea (Republic) in 1998 to that in 2001?
Ensure brevity in your answer.  0.9. What is the ratio of the Emissions(in percent) of Macedonia in 1998 to that in 2001?
Keep it short and to the point. 0.99. What is the ratio of the Emissions(in percent) of Philippines in 1998 to that in 2001?
Offer a terse response. 0.43. What is the ratio of the Emissions(in percent) in Sub-Saharan Africa (developing only) in 1998 to that in 2002?
Your response must be concise. 1.1. What is the ratio of the Emissions(in percent) of Korea (Republic) in 1998 to that in 2002?
Give a very brief answer. 0.89. What is the ratio of the Emissions(in percent) of Macedonia in 1998 to that in 2002?
Keep it short and to the point. 1.05. What is the ratio of the Emissions(in percent) of Philippines in 1998 to that in 2002?
Ensure brevity in your answer.  0.49. What is the ratio of the Emissions(in percent) of Sub-Saharan Africa (developing only) in 1999 to that in 2000?
Provide a short and direct response. 1.08. What is the ratio of the Emissions(in percent) of Korea (Republic) in 1999 to that in 2000?
Keep it short and to the point. 0.91. What is the ratio of the Emissions(in percent) of Macedonia in 1999 to that in 2000?
Offer a very short reply. 1.01. What is the ratio of the Emissions(in percent) of Philippines in 1999 to that in 2000?
Your answer should be compact. 0.77. What is the ratio of the Emissions(in percent) in Sub-Saharan Africa (developing only) in 1999 to that in 2001?
Offer a terse response. 1.08. What is the ratio of the Emissions(in percent) of Korea (Republic) in 1999 to that in 2001?
Offer a terse response. 0.86. What is the ratio of the Emissions(in percent) in Macedonia in 1999 to that in 2001?
Provide a short and direct response. 0.97. What is the ratio of the Emissions(in percent) in Philippines in 1999 to that in 2001?
Provide a succinct answer. 0.75. What is the ratio of the Emissions(in percent) of Sub-Saharan Africa (developing only) in 1999 to that in 2002?
Offer a terse response. 1.12. What is the ratio of the Emissions(in percent) in Korea (Republic) in 1999 to that in 2002?
Ensure brevity in your answer.  0.85. What is the ratio of the Emissions(in percent) in Macedonia in 1999 to that in 2002?
Provide a succinct answer. 1.03. What is the ratio of the Emissions(in percent) in Philippines in 1999 to that in 2002?
Offer a very short reply. 0.86. What is the ratio of the Emissions(in percent) in Korea (Republic) in 2000 to that in 2001?
Offer a very short reply. 0.95. What is the ratio of the Emissions(in percent) of Macedonia in 2000 to that in 2001?
Keep it short and to the point. 0.95. What is the ratio of the Emissions(in percent) of Philippines in 2000 to that in 2001?
Make the answer very short. 0.97. What is the ratio of the Emissions(in percent) in Sub-Saharan Africa (developing only) in 2000 to that in 2002?
Provide a short and direct response. 1.04. What is the ratio of the Emissions(in percent) of Korea (Republic) in 2000 to that in 2002?
Offer a very short reply. 0.94. What is the ratio of the Emissions(in percent) in Macedonia in 2000 to that in 2002?
Provide a succinct answer. 1.01. What is the ratio of the Emissions(in percent) of Philippines in 2000 to that in 2002?
Keep it short and to the point. 1.11. What is the ratio of the Emissions(in percent) of Sub-Saharan Africa (developing only) in 2001 to that in 2002?
Keep it short and to the point. 1.04. What is the ratio of the Emissions(in percent) in Korea (Republic) in 2001 to that in 2002?
Provide a succinct answer. 0.99. What is the ratio of the Emissions(in percent) in Macedonia in 2001 to that in 2002?
Your response must be concise. 1.06. What is the ratio of the Emissions(in percent) in Philippines in 2001 to that in 2002?
Provide a short and direct response. 1.15. What is the difference between the highest and the second highest Emissions(in percent) of Sub-Saharan Africa (developing only)?
Your answer should be compact. 0.78. What is the difference between the highest and the second highest Emissions(in percent) in Korea (Republic)?
Provide a short and direct response. 0.36. What is the difference between the highest and the second highest Emissions(in percent) of Macedonia?
Make the answer very short. 0.68. What is the difference between the highest and the second highest Emissions(in percent) in Philippines?
Offer a terse response. 0.79. What is the difference between the highest and the lowest Emissions(in percent) in Sub-Saharan Africa (developing only)?
Offer a terse response. 7.35. What is the difference between the highest and the lowest Emissions(in percent) of Korea (Republic)?
Offer a very short reply. 10.77. What is the difference between the highest and the lowest Emissions(in percent) in Macedonia?
Make the answer very short. 9.34. What is the difference between the highest and the lowest Emissions(in percent) of Philippines?
Your answer should be very brief. 13.55. 